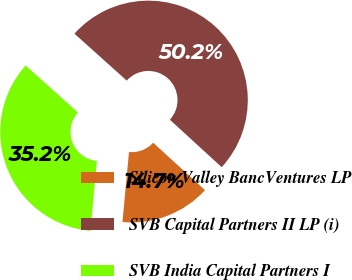<chart> <loc_0><loc_0><loc_500><loc_500><pie_chart><fcel>Silicon Valley BancVentures LP<fcel>SVB Capital Partners II LP (i)<fcel>SVB India Capital Partners I<nl><fcel>14.68%<fcel>50.16%<fcel>35.16%<nl></chart> 